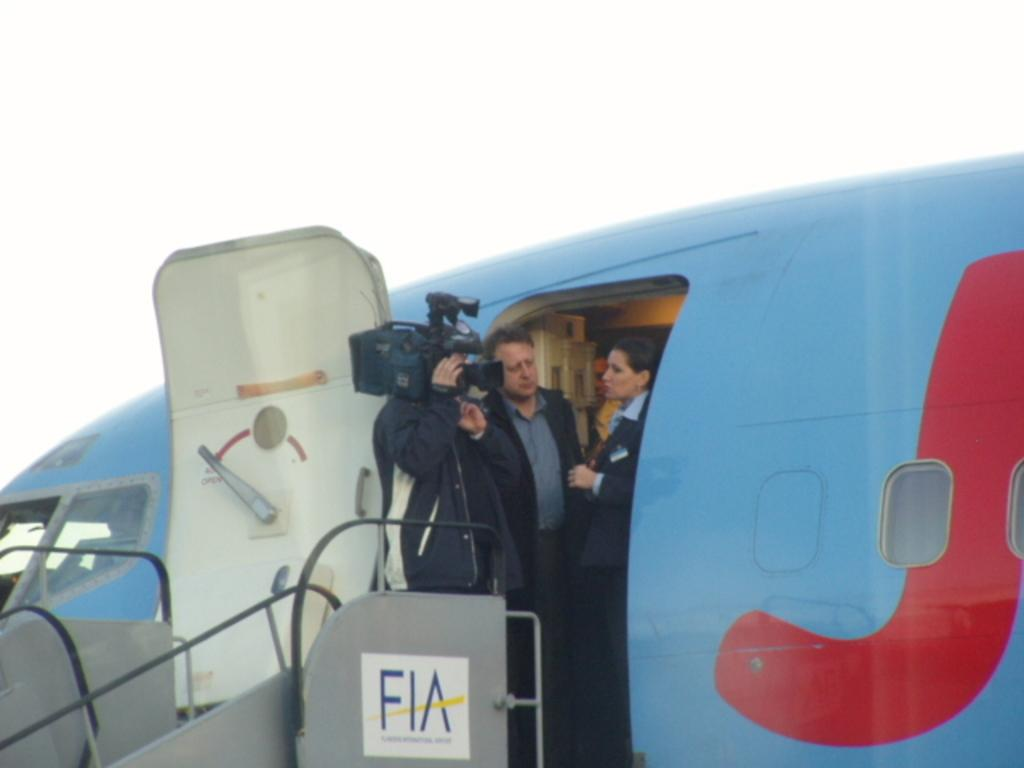<image>
Summarize the visual content of the image. A Cameraman stands on the top of FIA labelled stairs at a plane door. 